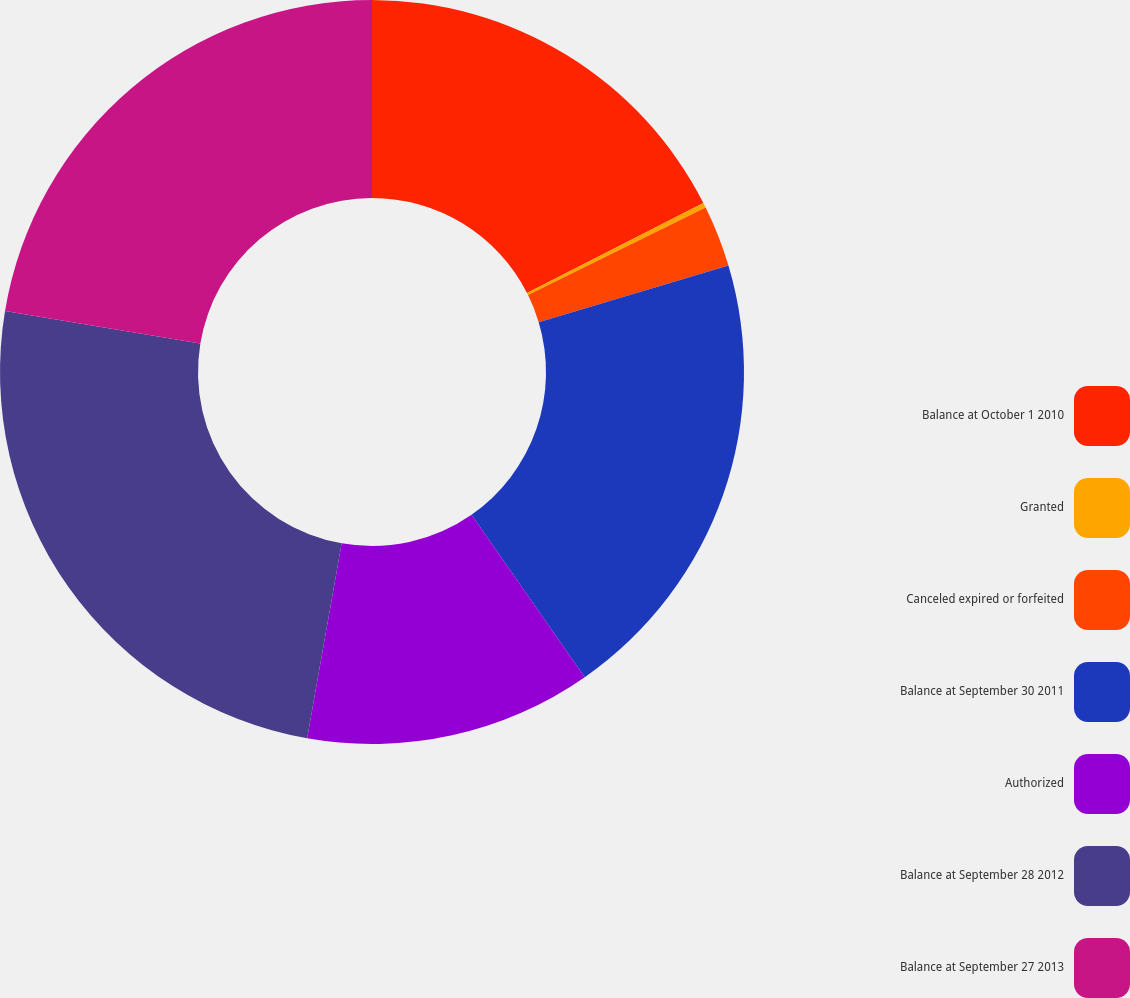Convert chart to OTSL. <chart><loc_0><loc_0><loc_500><loc_500><pie_chart><fcel>Balance at October 1 2010<fcel>Granted<fcel>Canceled expired or forfeited<fcel>Balance at September 30 2011<fcel>Authorized<fcel>Balance at September 28 2012<fcel>Balance at September 27 2013<nl><fcel>17.49%<fcel>0.22%<fcel>2.67%<fcel>19.93%<fcel>12.48%<fcel>24.83%<fcel>22.38%<nl></chart> 